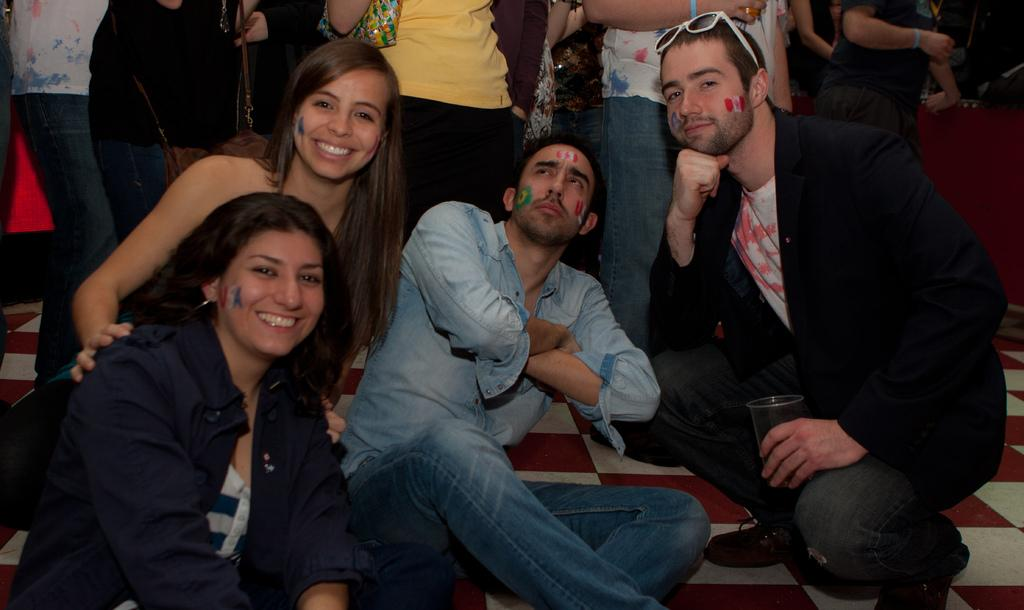How many people are in the image? There are people in the image. Can you describe the expressions of the people in the image? Two people are smiling in the image. What is the man holding in the image? The man is holding a cup in the image. What action is one of the people performing in the image? A person is giving a still in the image. What type of wood can be seen in the image? There is no wood present in the image. What news event is being discussed in the image? There is no news event being discussed in the image. 